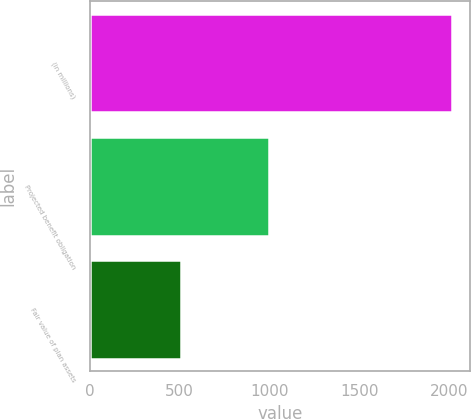Convert chart. <chart><loc_0><loc_0><loc_500><loc_500><bar_chart><fcel>(in millions)<fcel>Projected benefit obligation<fcel>Fair value of plan assets<nl><fcel>2015<fcel>999<fcel>506<nl></chart> 